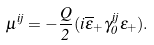Convert formula to latex. <formula><loc_0><loc_0><loc_500><loc_500>\mu ^ { i j } = - \frac { Q } { 2 } ( i \overline { \epsilon } _ { + } \gamma _ { 0 } ^ { i j } \epsilon _ { + } ) .</formula> 